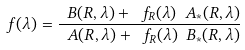Convert formula to latex. <formula><loc_0><loc_0><loc_500><loc_500>\ f ( \lambda ) = \frac { \ B ( R , \lambda ) + \ f _ { R } ( \lambda ) \ A _ { \ast } ( R , \lambda ) } { \ A ( R , \lambda ) + \ f _ { R } ( \lambda ) \ B _ { \ast } ( R , \lambda ) }</formula> 